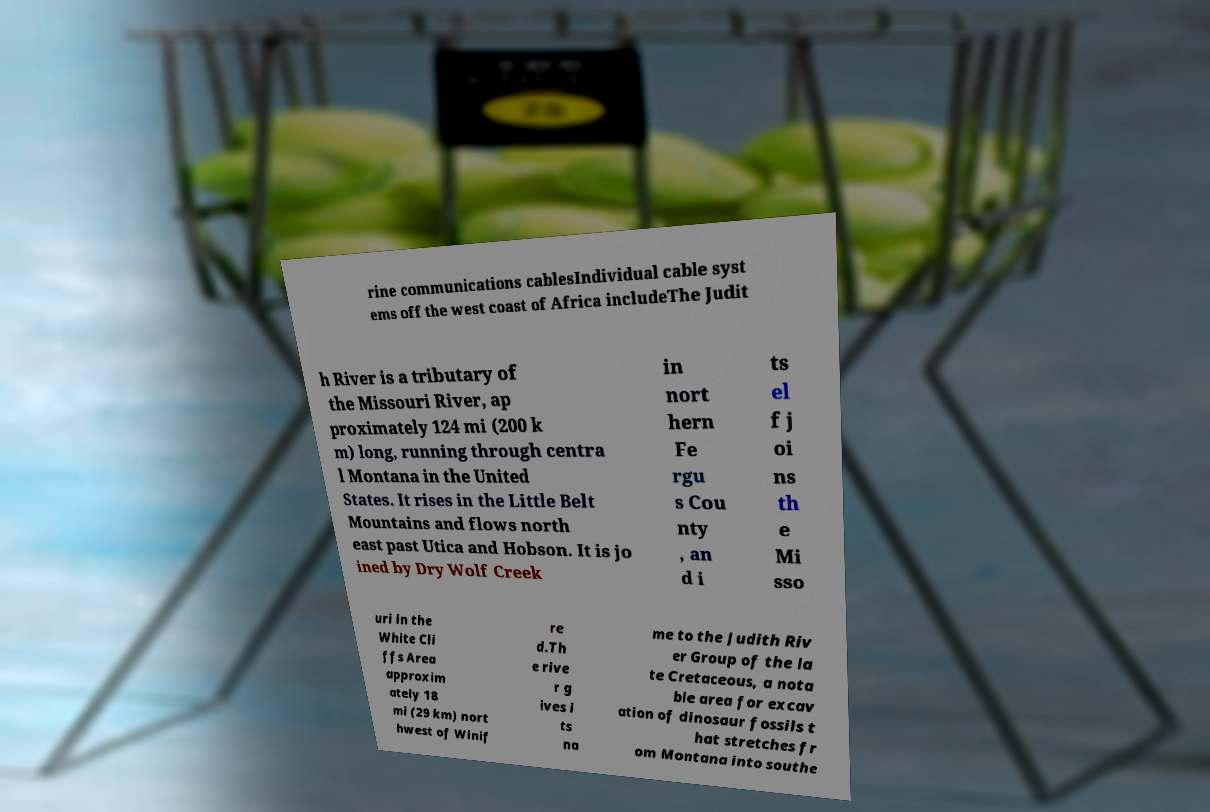For documentation purposes, I need the text within this image transcribed. Could you provide that? rine communications cablesIndividual cable syst ems off the west coast of Africa includeThe Judit h River is a tributary of the Missouri River, ap proximately 124 mi (200 k m) long, running through centra l Montana in the United States. It rises in the Little Belt Mountains and flows north east past Utica and Hobson. It is jo ined by Dry Wolf Creek in nort hern Fe rgu s Cou nty , an d i ts el f j oi ns th e Mi sso uri in the White Cli ffs Area approxim ately 18 mi (29 km) nort hwest of Winif re d.Th e rive r g ives i ts na me to the Judith Riv er Group of the la te Cretaceous, a nota ble area for excav ation of dinosaur fossils t hat stretches fr om Montana into southe 